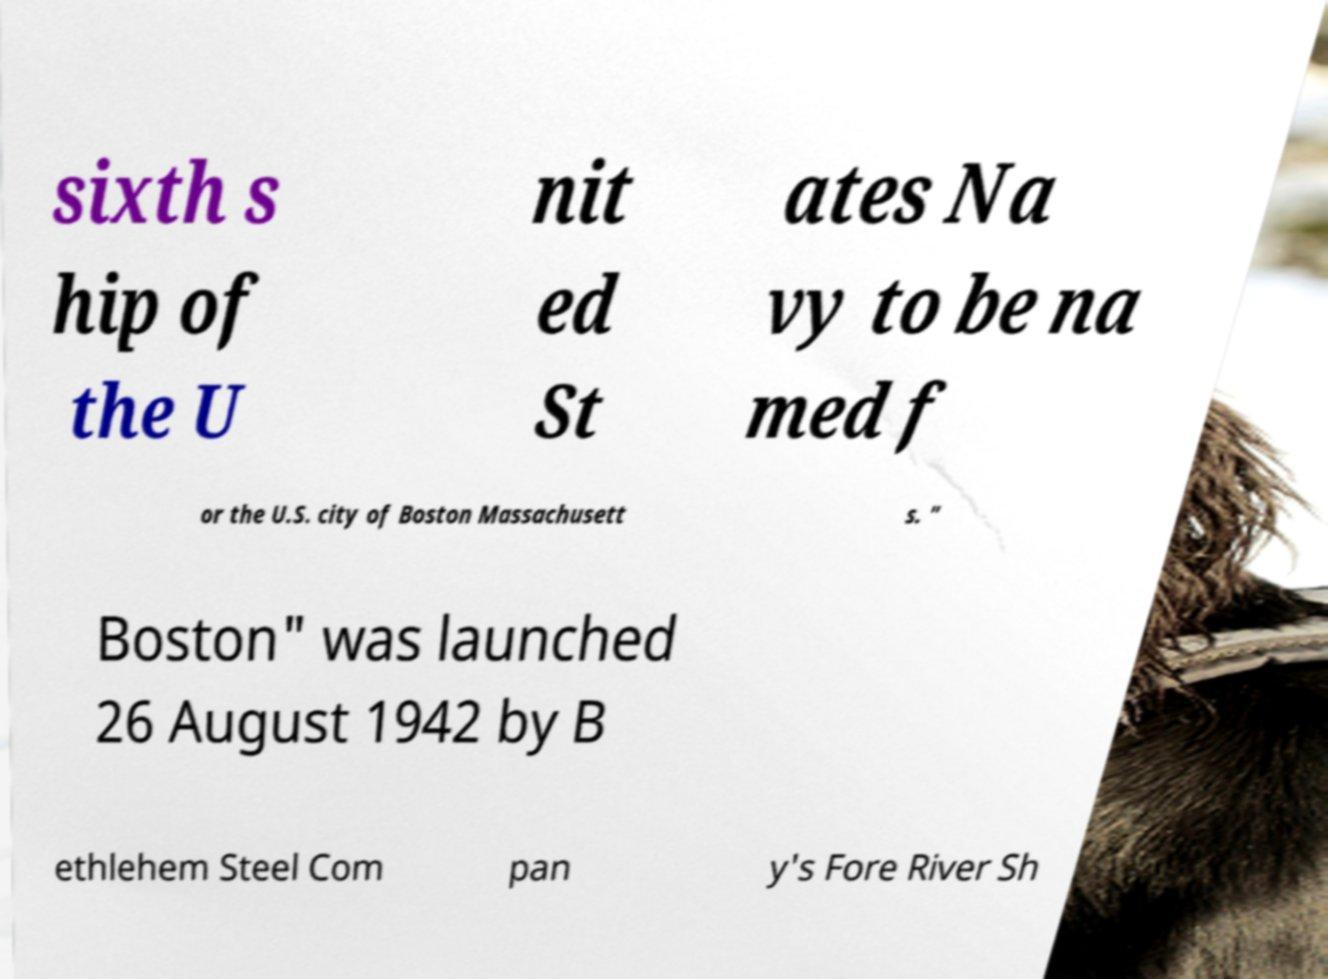Please read and relay the text visible in this image. What does it say? sixth s hip of the U nit ed St ates Na vy to be na med f or the U.S. city of Boston Massachusett s. " Boston" was launched 26 August 1942 by B ethlehem Steel Com pan y's Fore River Sh 